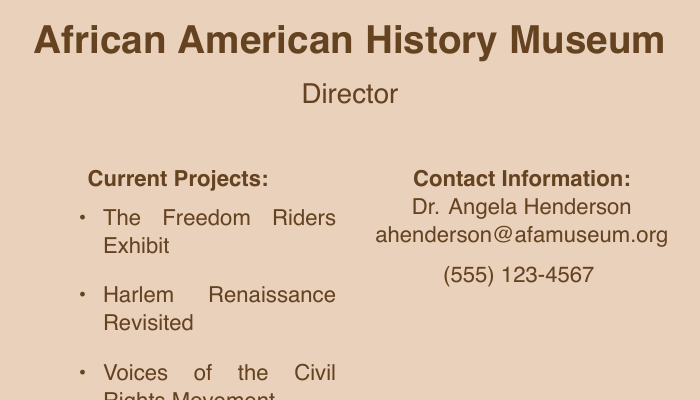What are the current projects? The current projects list includes specific ongoing or upcoming projects aiming to preserve and celebrate African American history.
Answer: The Freedom Riders Exhibit, Harlem Renaissance Revisited, Voices of the Civil Rights Movement Who is the director? The document provides the name of the director of the museum, which is important for contact purposes.
Answer: Dr. Angela Henderson What is the email address? The document includes a contact email, which is relevant for inquiries related to the museum.
Answer: ahenderson@afamuseum.org What is the phone number? A phone number is provided for direct communication regarding museum projects.
Answer: (555) 123-4567 What type of institution is this card for? Understanding the type of institution will give context to the projects listed.
Answer: African American History Museum How many current projects are listed? This question requires counting the items listed under current projects in the document.
Answer: Three What is the main purpose stated on the card? The card expresses the overall mission of the museum, giving insight into its focus.
Answer: Preserving and Celebrating African American History What color is the background? The background color sets the tone of the document and can relate to its thematic elements.
Answer: Light brown 